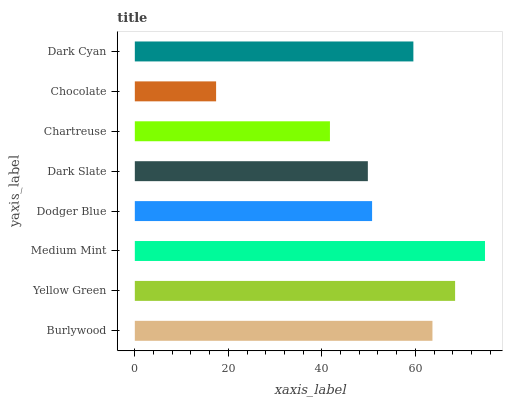Is Chocolate the minimum?
Answer yes or no. Yes. Is Medium Mint the maximum?
Answer yes or no. Yes. Is Yellow Green the minimum?
Answer yes or no. No. Is Yellow Green the maximum?
Answer yes or no. No. Is Yellow Green greater than Burlywood?
Answer yes or no. Yes. Is Burlywood less than Yellow Green?
Answer yes or no. Yes. Is Burlywood greater than Yellow Green?
Answer yes or no. No. Is Yellow Green less than Burlywood?
Answer yes or no. No. Is Dark Cyan the high median?
Answer yes or no. Yes. Is Dodger Blue the low median?
Answer yes or no. Yes. Is Dodger Blue the high median?
Answer yes or no. No. Is Dark Slate the low median?
Answer yes or no. No. 